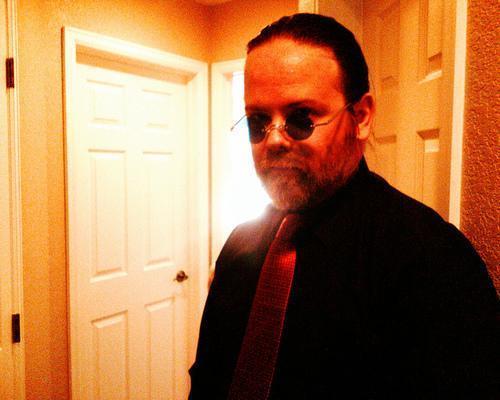How many people are there?
Give a very brief answer. 1. How many clocks are in this picture?
Give a very brief answer. 0. 